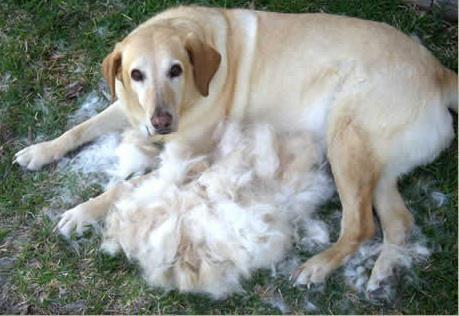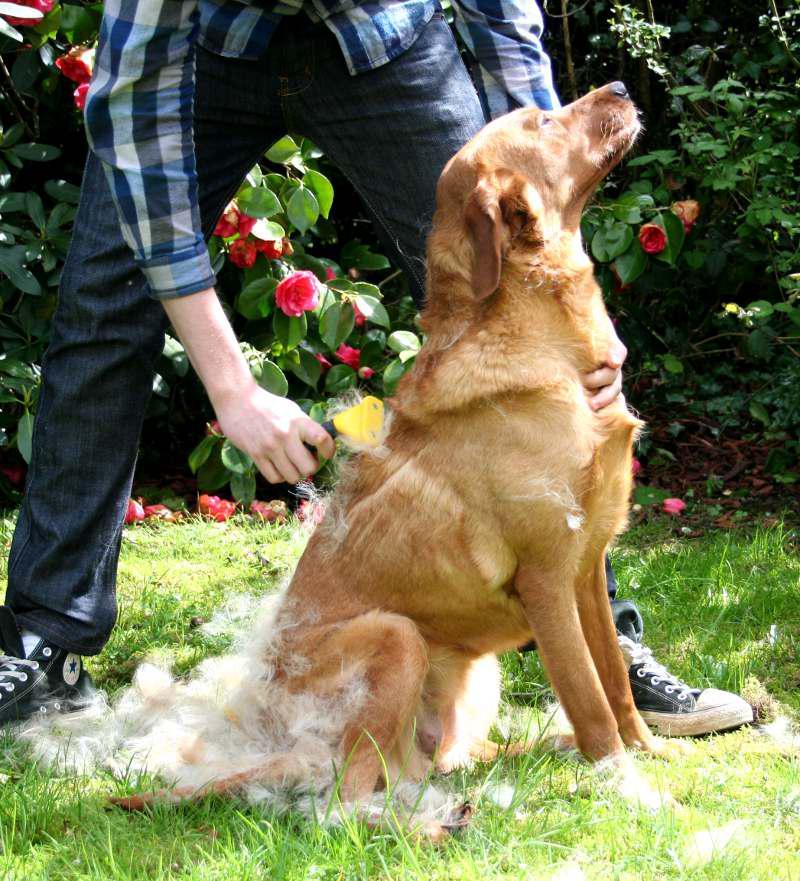The first image is the image on the left, the second image is the image on the right. Given the left and right images, does the statement "There is exactly one adult dog lying in the grass." hold true? Answer yes or no. Yes. The first image is the image on the left, the second image is the image on the right. Given the left and right images, does the statement "There is exactly one sitting dog in one of the images." hold true? Answer yes or no. Yes. 